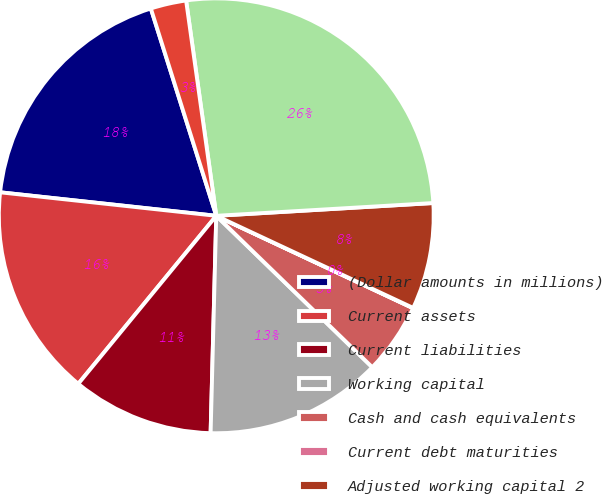Convert chart. <chart><loc_0><loc_0><loc_500><loc_500><pie_chart><fcel>(Dollar amounts in millions)<fcel>Current assets<fcel>Current liabilities<fcel>Working capital<fcel>Cash and cash equivalents<fcel>Current debt maturities<fcel>Adjusted working capital 2<fcel>Annualized sales 1<fcel>Adjusted working capital as a<nl><fcel>18.41%<fcel>15.78%<fcel>10.53%<fcel>13.15%<fcel>5.28%<fcel>0.02%<fcel>7.9%<fcel>26.28%<fcel>2.65%<nl></chart> 